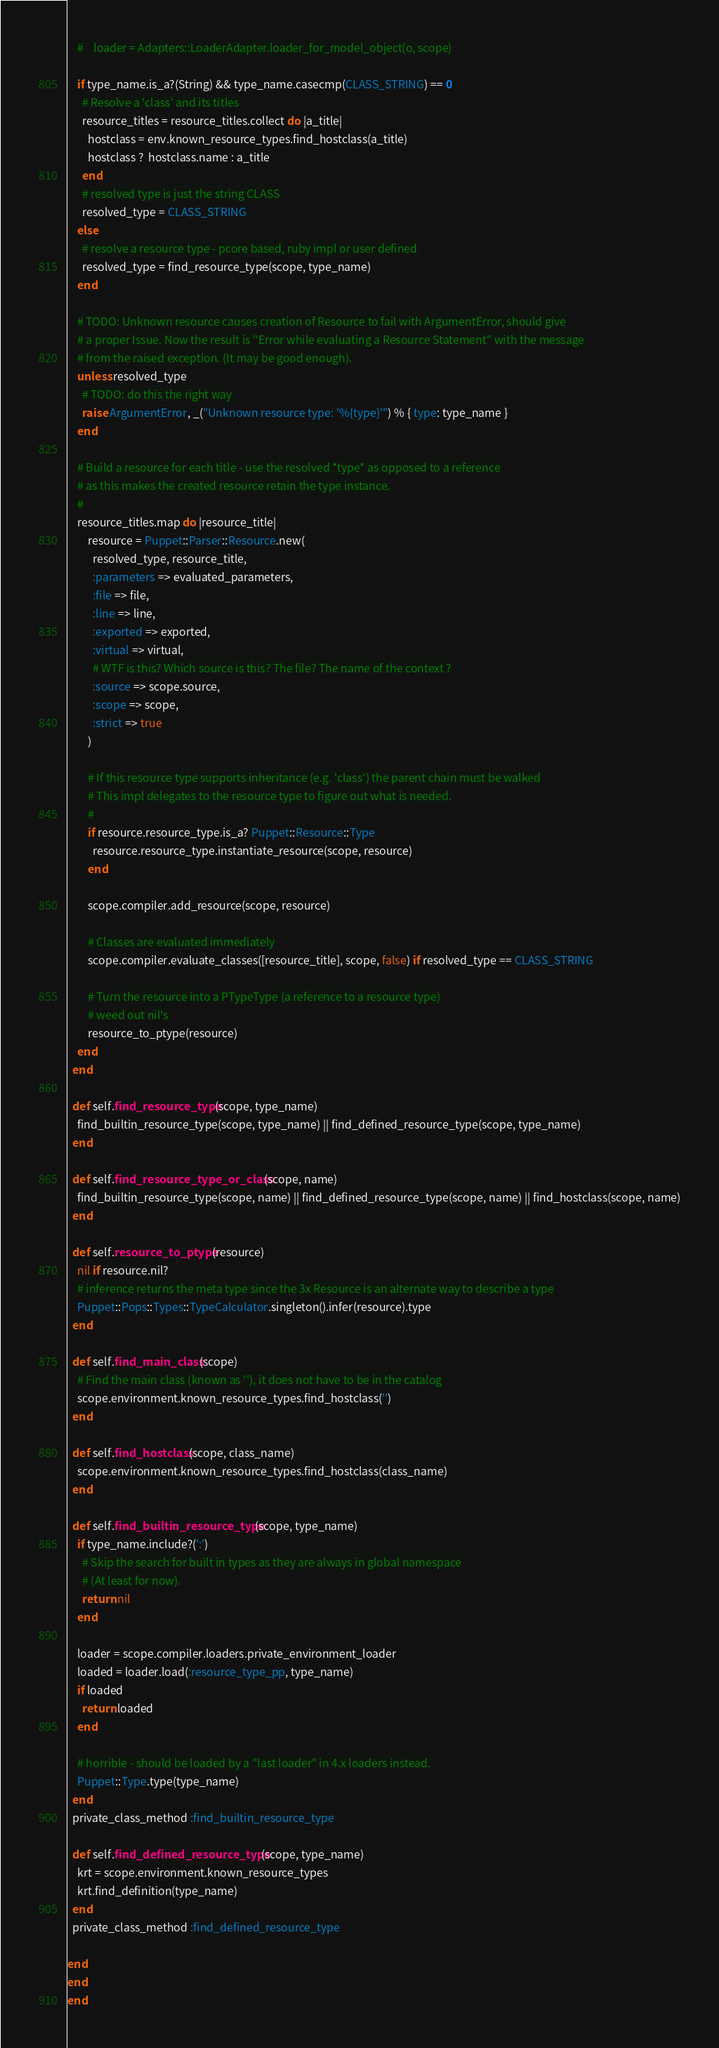<code> <loc_0><loc_0><loc_500><loc_500><_Ruby_>    #    loader = Adapters::LoaderAdapter.loader_for_model_object(o, scope)

    if type_name.is_a?(String) && type_name.casecmp(CLASS_STRING) == 0
      # Resolve a 'class' and its titles
      resource_titles = resource_titles.collect do |a_title|
        hostclass = env.known_resource_types.find_hostclass(a_title)
        hostclass ?  hostclass.name : a_title
      end
      # resolved type is just the string CLASS
      resolved_type = CLASS_STRING
    else
      # resolve a resource type - pcore based, ruby impl or user defined
      resolved_type = find_resource_type(scope, type_name)
    end

    # TODO: Unknown resource causes creation of Resource to fail with ArgumentError, should give
    # a proper Issue. Now the result is "Error while evaluating a Resource Statement" with the message
    # from the raised exception. (It may be good enough).
    unless resolved_type
      # TODO: do this the right way
      raise ArgumentError, _("Unknown resource type: '%{type}'") % { type: type_name }
    end

    # Build a resource for each title - use the resolved *type* as opposed to a reference
    # as this makes the created resource retain the type instance.
    #
    resource_titles.map do |resource_title|
        resource = Puppet::Parser::Resource.new(
          resolved_type, resource_title,
          :parameters => evaluated_parameters,
          :file => file,
          :line => line,
          :exported => exported,
          :virtual => virtual,
          # WTF is this? Which source is this? The file? The name of the context ?
          :source => scope.source,
          :scope => scope,
          :strict => true
        )

        # If this resource type supports inheritance (e.g. 'class') the parent chain must be walked
        # This impl delegates to the resource type to figure out what is needed.
        #
        if resource.resource_type.is_a? Puppet::Resource::Type
          resource.resource_type.instantiate_resource(scope, resource)
        end

        scope.compiler.add_resource(scope, resource)

        # Classes are evaluated immediately
        scope.compiler.evaluate_classes([resource_title], scope, false) if resolved_type == CLASS_STRING

        # Turn the resource into a PTypeType (a reference to a resource type)
        # weed out nil's
        resource_to_ptype(resource)
    end
  end

  def self.find_resource_type(scope, type_name)
    find_builtin_resource_type(scope, type_name) || find_defined_resource_type(scope, type_name)
  end

  def self.find_resource_type_or_class(scope, name)
    find_builtin_resource_type(scope, name) || find_defined_resource_type(scope, name) || find_hostclass(scope, name)
  end

  def self.resource_to_ptype(resource)
    nil if resource.nil?
    # inference returns the meta type since the 3x Resource is an alternate way to describe a type
    Puppet::Pops::Types::TypeCalculator.singleton().infer(resource).type
  end

  def self.find_main_class(scope)
    # Find the main class (known as ''), it does not have to be in the catalog
    scope.environment.known_resource_types.find_hostclass('')
  end

  def self.find_hostclass(scope, class_name)
    scope.environment.known_resource_types.find_hostclass(class_name)
  end

  def self.find_builtin_resource_type(scope, type_name)
    if type_name.include?(':')
      # Skip the search for built in types as they are always in global namespace
      # (At least for now).
      return nil
    end

    loader = scope.compiler.loaders.private_environment_loader
    loaded = loader.load(:resource_type_pp, type_name)
    if loaded
      return loaded
    end

    # horrible - should be loaded by a "last loader" in 4.x loaders instead.
    Puppet::Type.type(type_name)
  end
  private_class_method :find_builtin_resource_type

  def self.find_defined_resource_type(scope, type_name)
    krt = scope.environment.known_resource_types
    krt.find_definition(type_name)
  end
  private_class_method :find_defined_resource_type

end
end
end
</code> 